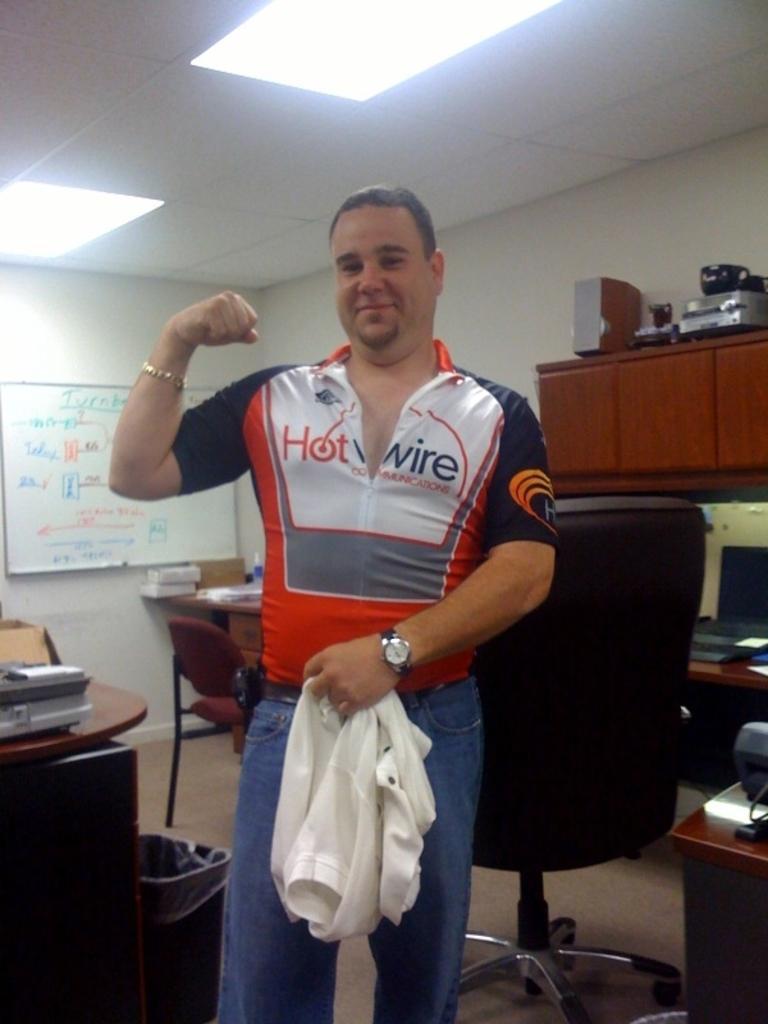Please provide a concise description of this image. In the middle of the image a man is standing and smiling. Behind him there is a chair and there is a table. Top right side of the image there is a cupboard and there is a wall. Top of the image there is roof and lights. Top left side of the image there is a board. Bottom left side of the image there is a table on the table there are some products. Bottom right side of the image there is a table on the table there is a laptop and there are some devices. 